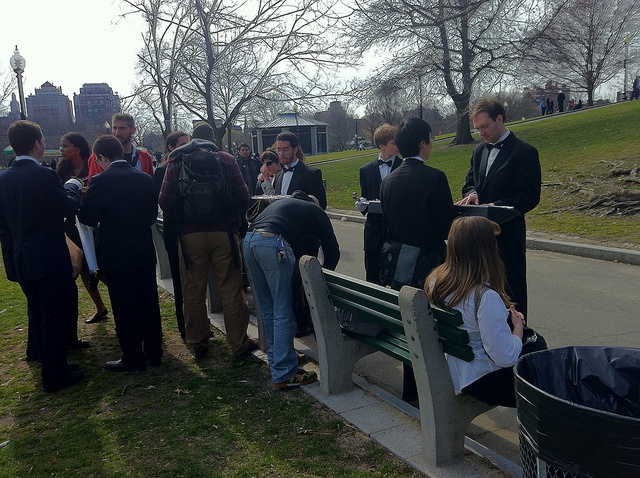Describe the objects in this image and their specific colors. I can see bench in ivory, black, gray, and purple tones, people in ivory, black, gray, and darkgreen tones, people in white, black, and gray tones, people in ivory, black, gray, and maroon tones, and people in ivory, black, and gray tones in this image. 